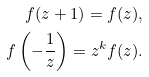Convert formula to latex. <formula><loc_0><loc_0><loc_500><loc_500>f ( z + 1 ) = f ( z ) , \\ f \left ( - \frac { 1 } { z } \right ) = z ^ { k } f ( z ) .</formula> 